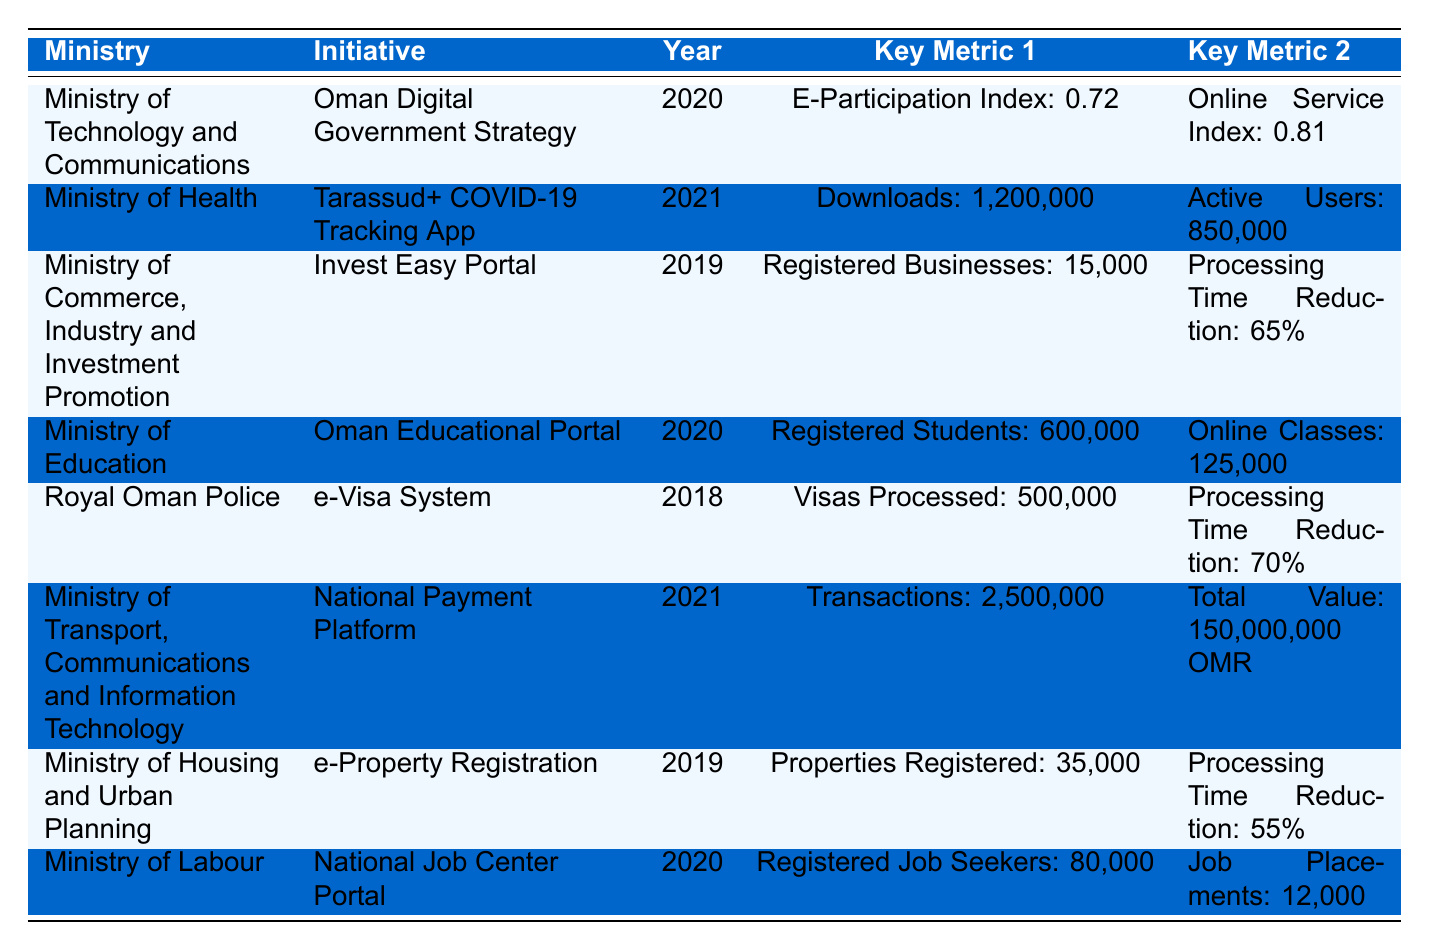What is the user satisfaction rate for the e-Visa System? The user satisfaction rate for the e-Visa System is listed in the table under the Royal Oman Police's entry. It shows a rate of 89%.
Answer: 89% How many registered students are there in the Oman Educational Portal? The table states that the number of registered students in the Oman Educational Portal is 600,000, which is indicated in the entry for the Ministry of Education.
Answer: 600,000 What was the processing time reduction for the Invest Easy Portal? According to the data for the Ministry of Commerce, Industry and Investment Promotion, the processing time reduction for the Invest Easy Portal is 65%.
Answer: 65% Which initiative had the highest number of transactions processed? The initiative with the highest number of transactions processed is the National Payment Platform, which processed 2,500,000 transactions, as shown in the entry for the Ministry of Transport, Communications and Information Technology.
Answer: National Payment Platform What is the average user satisfaction rate for the initiatives listed? We need to add the user satisfaction rates: 85 (Oman Digital Government Strategy) + 78 (Invest Easy Portal) + 89 (e-Visa System) + 82 (e-Property Registration) + 76 (National Job Center Portal) = 410. There are 5 initiatives, so the average user satisfaction rate is 410 / 5 = 82%.
Answer: 82% Was the Tarassud+ COVID-19 Tracking App launched in 2020? The Tarassud+ COVID-19 Tracking App is listed under the Ministry of Health, and its year is 2021, so the answer is no.
Answer: No How many more properties were registered under e-Property Registration compared to registered job seekers in the National Job Center Portal? The e-Property Registration showed 35,000 properties registered, while the National Job Center Portal had 80,000 registered job seekers. To find the difference: 80,000 - 35,000 = 45,000.
Answer: 45,000 What was the total value of transactions processed by the National Payment Platform? The total transaction value for the National Payment Platform is provided as 150,000,000 OMR in the entry for the Ministry of Transport, Communications and Information Technology.
Answer: 150,000,000 OMR Is the e-participation index for the Oman Digital Government Strategy greater than 0.75? The e-participation index listed for the Oman Digital Government Strategy is 0.72, which means it is not greater than 0.75.
Answer: No Which initiative had the most active users in 2021? Active users for the Tarassud+ COVID-19 Tracking App is provided as 850,000, which is higher than any other initiative listed, thus making it the one with the most active users in 2021.
Answer: Tarassud+ COVID-19 Tracking App 